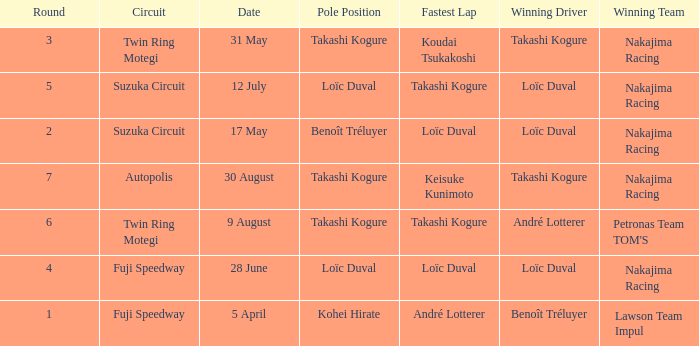Who was the driver for the winning team Lawson Team Impul? Benoît Tréluyer. 